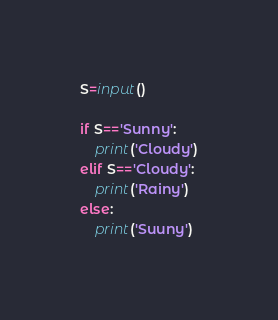<code> <loc_0><loc_0><loc_500><loc_500><_Python_>S=input()

if S=='Sunny':
    print('Cloudy')
elif S=='Cloudy':
    print('Rainy')
else:
    print('Suuny')</code> 